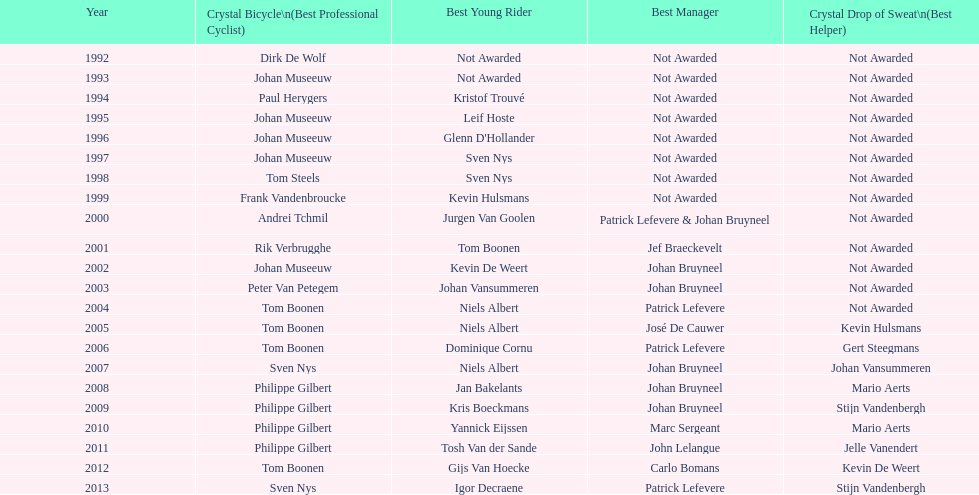Could you parse the entire table? {'header': ['Year', 'Crystal Bicycle\\n(Best Professional Cyclist)', 'Best Young Rider', 'Best Manager', 'Crystal Drop of Sweat\\n(Best Helper)'], 'rows': [['1992', 'Dirk De Wolf', 'Not Awarded', 'Not Awarded', 'Not Awarded'], ['1993', 'Johan Museeuw', 'Not Awarded', 'Not Awarded', 'Not Awarded'], ['1994', 'Paul Herygers', 'Kristof Trouvé', 'Not Awarded', 'Not Awarded'], ['1995', 'Johan Museeuw', 'Leif Hoste', 'Not Awarded', 'Not Awarded'], ['1996', 'Johan Museeuw', "Glenn D'Hollander", 'Not Awarded', 'Not Awarded'], ['1997', 'Johan Museeuw', 'Sven Nys', 'Not Awarded', 'Not Awarded'], ['1998', 'Tom Steels', 'Sven Nys', 'Not Awarded', 'Not Awarded'], ['1999', 'Frank Vandenbroucke', 'Kevin Hulsmans', 'Not Awarded', 'Not Awarded'], ['2000', 'Andrei Tchmil', 'Jurgen Van Goolen', 'Patrick Lefevere & Johan Bruyneel', 'Not Awarded'], ['2001', 'Rik Verbrugghe', 'Tom Boonen', 'Jef Braeckevelt', 'Not Awarded'], ['2002', 'Johan Museeuw', 'Kevin De Weert', 'Johan Bruyneel', 'Not Awarded'], ['2003', 'Peter Van Petegem', 'Johan Vansummeren', 'Johan Bruyneel', 'Not Awarded'], ['2004', 'Tom Boonen', 'Niels Albert', 'Patrick Lefevere', 'Not Awarded'], ['2005', 'Tom Boonen', 'Niels Albert', 'José De Cauwer', 'Kevin Hulsmans'], ['2006', 'Tom Boonen', 'Dominique Cornu', 'Patrick Lefevere', 'Gert Steegmans'], ['2007', 'Sven Nys', 'Niels Albert', 'Johan Bruyneel', 'Johan Vansummeren'], ['2008', 'Philippe Gilbert', 'Jan Bakelants', 'Johan Bruyneel', 'Mario Aerts'], ['2009', 'Philippe Gilbert', 'Kris Boeckmans', 'Johan Bruyneel', 'Stijn Vandenbergh'], ['2010', 'Philippe Gilbert', 'Yannick Eijssen', 'Marc Sergeant', 'Mario Aerts'], ['2011', 'Philippe Gilbert', 'Tosh Van der Sande', 'John Lelangue', 'Jelle Vanendert'], ['2012', 'Tom Boonen', 'Gijs Van Hoecke', 'Carlo Bomans', 'Kevin De Weert'], ['2013', 'Sven Nys', 'Igor Decraene', 'Patrick Lefevere', 'Stijn Vandenbergh']]} What is the typical number of times johan museeuw appeared? 5. 